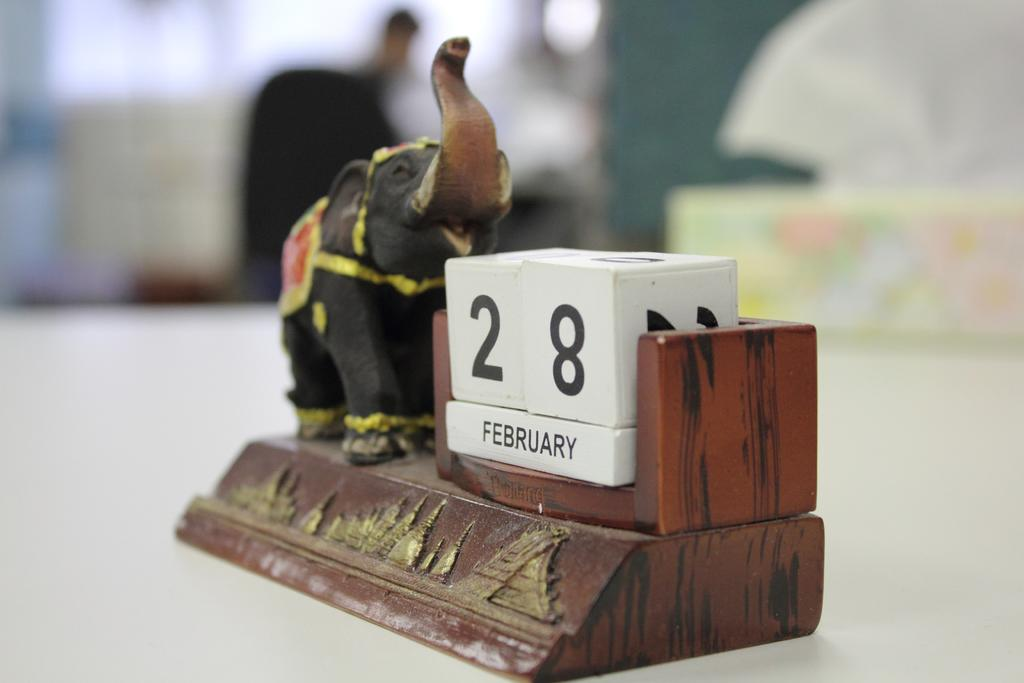Provide a one-sentence caption for the provided image. A wooden calendar brown sculpture with an elephant showing the date February 28. 